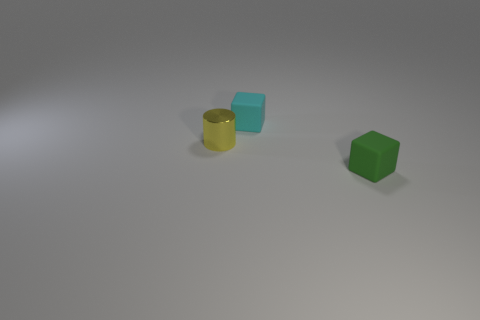Add 1 tiny gray balls. How many objects exist? 4 Add 1 green matte objects. How many green matte objects are left? 2 Add 2 tiny matte blocks. How many tiny matte blocks exist? 4 Subtract 0 yellow blocks. How many objects are left? 3 Subtract all cylinders. How many objects are left? 2 Subtract all big purple metallic cubes. Subtract all small cyan matte objects. How many objects are left? 2 